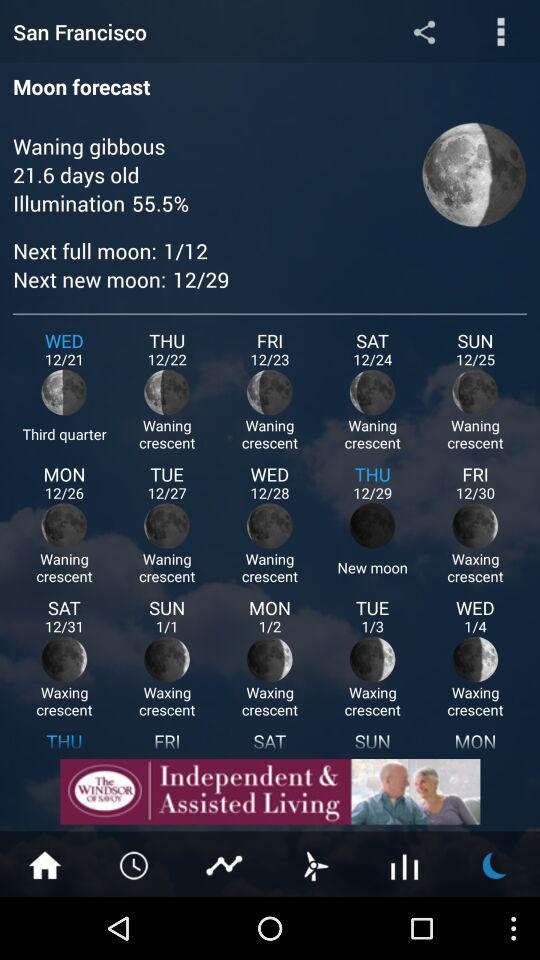What is the date of the next full moon? The date is January 12. 